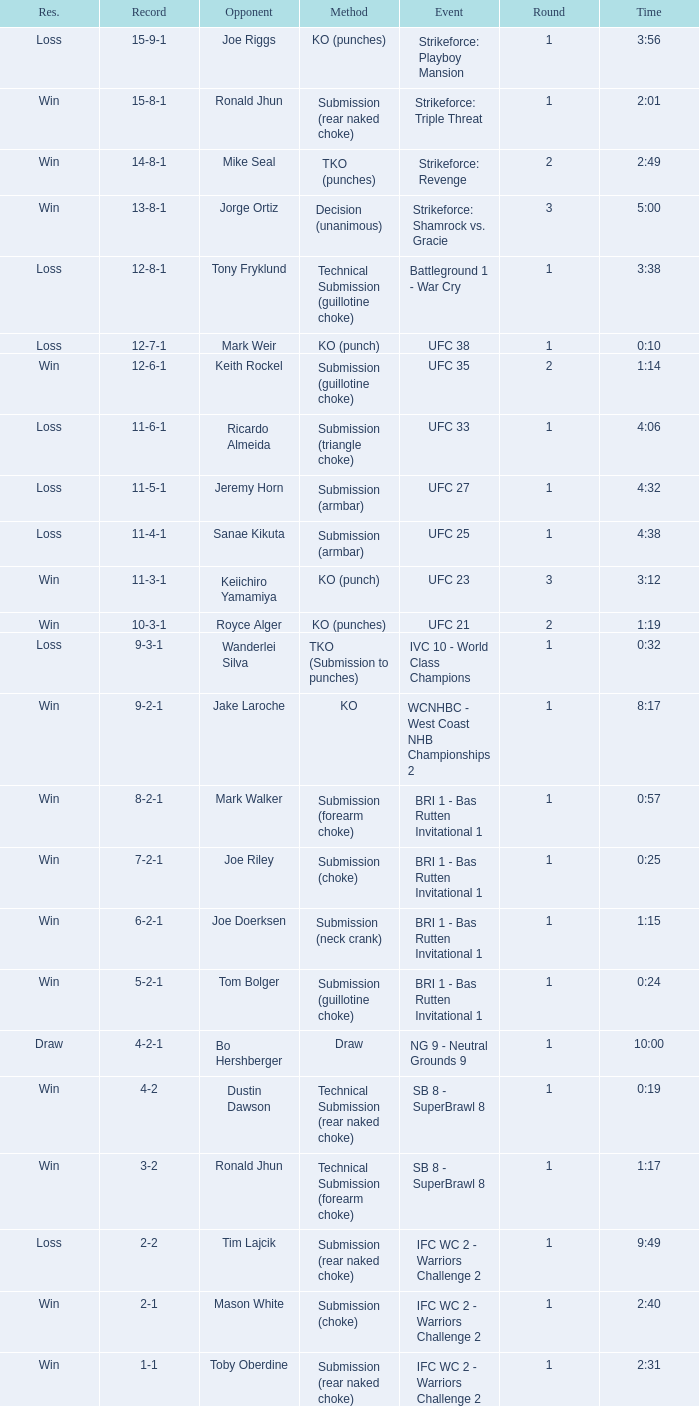Who was the opponent when the fight had a time of 2:01? Ronald Jhun. 